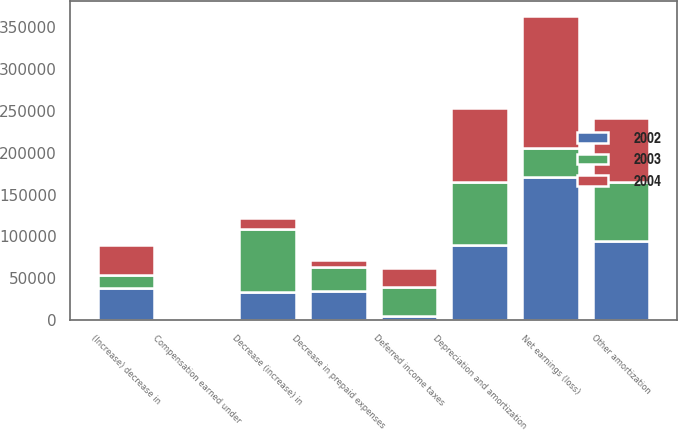<chart> <loc_0><loc_0><loc_500><loc_500><stacked_bar_chart><ecel><fcel>Net earnings (loss)<fcel>Depreciation and amortization<fcel>Other amortization<fcel>Deferred income taxes<fcel>Compensation earned under<fcel>Decrease (increase) in<fcel>(Increase) decrease in<fcel>Decrease in prepaid expenses<nl><fcel>2003<fcel>34735<fcel>75618<fcel>70562<fcel>34624<fcel>138<fcel>75590<fcel>15838<fcel>29423<nl><fcel>2004<fcel>157664<fcel>88070<fcel>76053<fcel>22774<fcel>172<fcel>13202<fcel>34846<fcel>7845<nl><fcel>2002<fcel>170674<fcel>89262<fcel>94576<fcel>5441<fcel>1770<fcel>33653<fcel>38783<fcel>34735<nl></chart> 